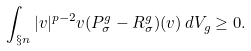Convert formula to latex. <formula><loc_0><loc_0><loc_500><loc_500>\int _ { \S n } | v | ^ { p - 2 } v ( P ^ { g } _ { \sigma } - R _ { \sigma } ^ { g } ) ( v ) \, d V _ { g } \geq 0 .</formula> 